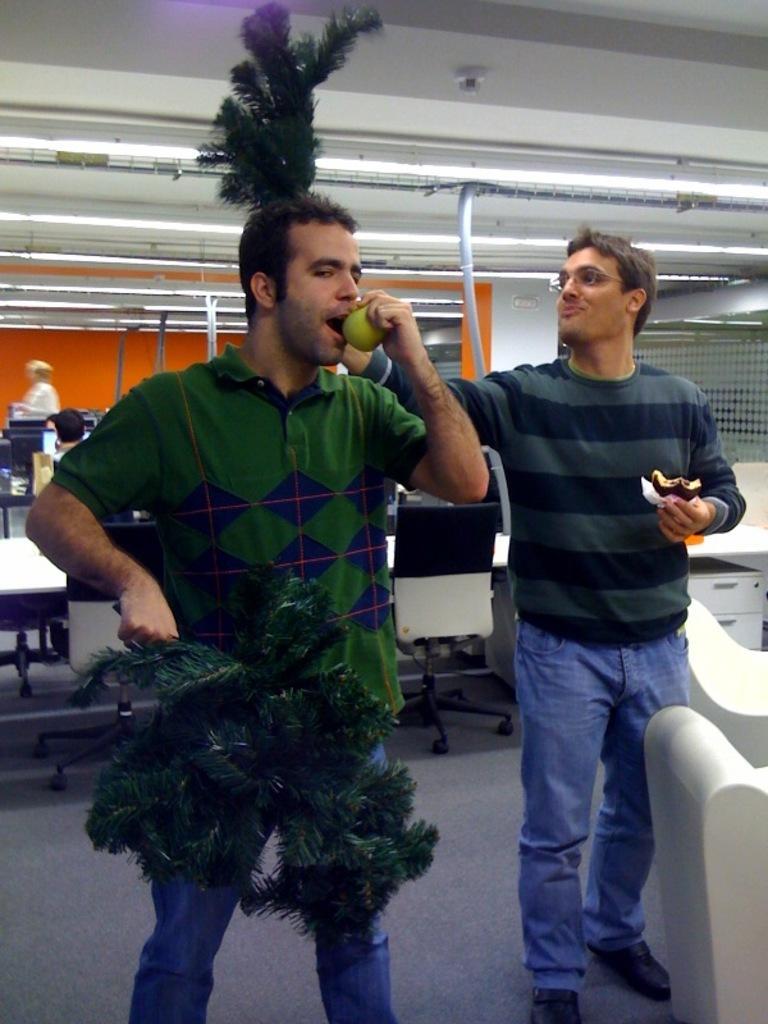Could you give a brief overview of what you see in this image? In this image I can see two people are standing and holding something and wearing different color dresses. I can see few chairs,few systems and tables. Back I can see an orange wall and lights. 